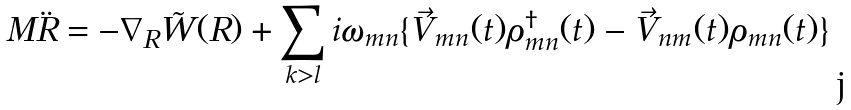<formula> <loc_0><loc_0><loc_500><loc_500>M \ddot { R } = - \nabla _ { R } \tilde { W } ( R ) + \sum _ { k > l } { i \omega _ { m n } \{ \vec { V } _ { m n } ( t ) \rho _ { m n } ^ { \dagger } ( t ) - \vec { V } _ { n m } ( t ) \rho _ { m n } ( t ) \} }</formula> 